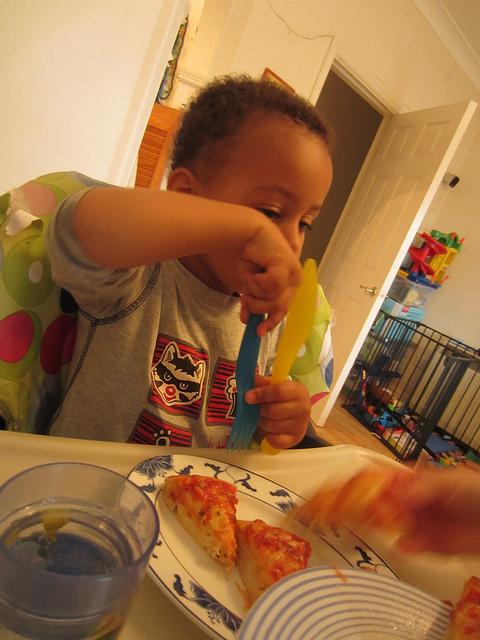<image>What brand of water is on the table? I am not sure which brand of water is on the table. It can be Evian, Aquafina, or just tap water. What brand of water is on the table? It is unclear what brand of water is on the table. It could be 'evian', 'tap', 'aquafina', or 'avian'. 